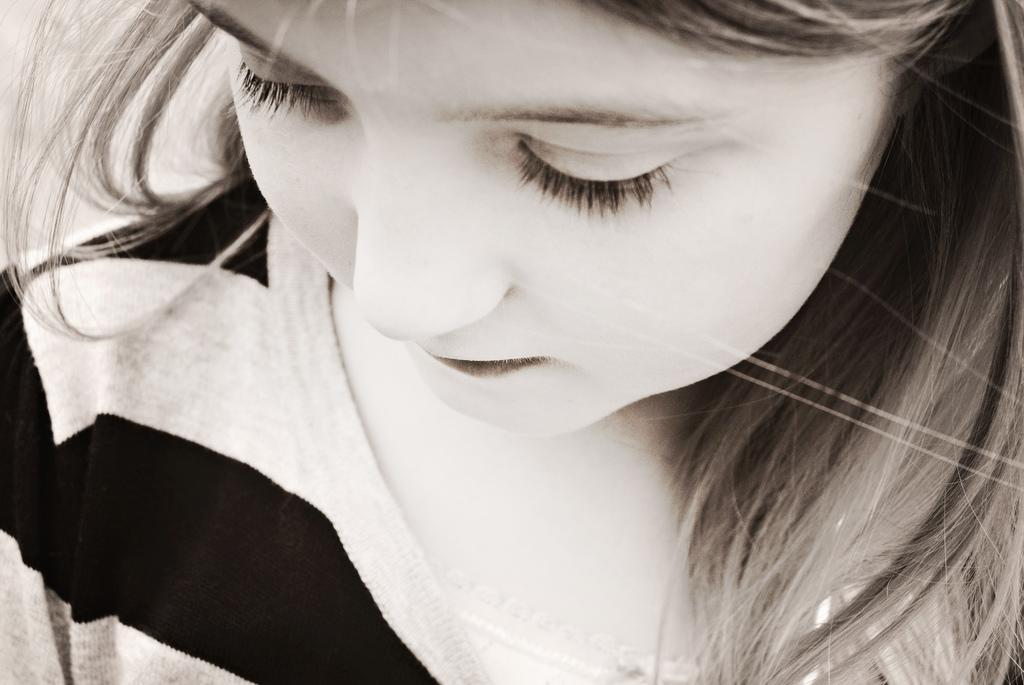What is the color scheme of the image? The image is black and white. What is the main subject of the image? The image is a zoomed picture of a girl. What is the condition of the street in the image? There is no street present in the image; it is a zoomed picture of a girl. Can you describe the girl blowing a bubble in the image? There is no bubble or blowing action depicted in the image, as it is a black and white zoomed picture of a girl. 